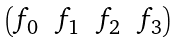<formula> <loc_0><loc_0><loc_500><loc_500>\begin{pmatrix} f _ { 0 } & f _ { 1 } & f _ { 2 } & f _ { 3 } \end{pmatrix}</formula> 